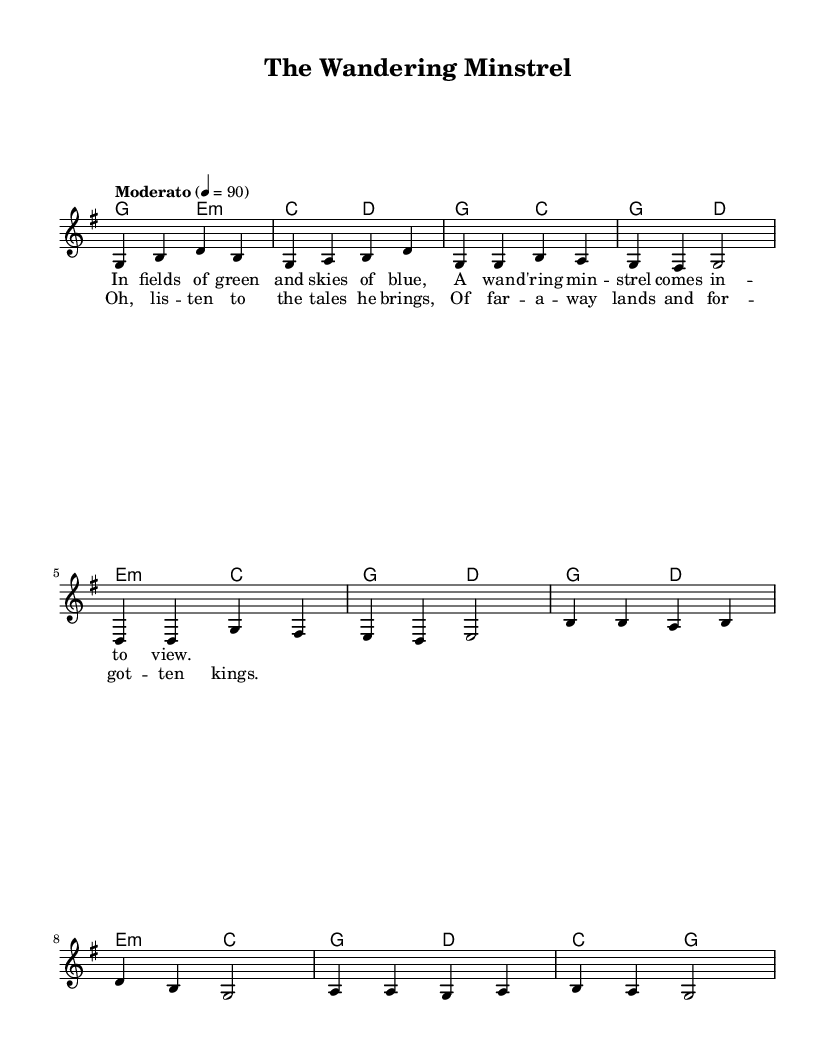What is the key signature of this music? The key signature is G major, which has one sharp (F#). This is determined by the presence of the F# note throughout the piece, characteristic of the G major scale.
Answer: G major What is the time signature of this music? The time signature is 4/4, meaning there are four beats per measure, and a quarter note gets one beat. This can be identified by the notation at the start of the score indicating 4/4.
Answer: 4/4 What is the tempo marking for this piece? The tempo marking is "Moderato," which indicates a moderate tempo. It is given in the header of the music with the metronome marking of 90 beats per minute.
Answer: Moderato How many measures are in the verse section? The verse section consists of four measures. This can be counted by identifying the phrases in the notation and counting each bar line in the verse section.
Answer: 4 What is the primary theme of the lyrics? The primary theme of the lyrics revolves around storytelling and adventure, evident from lines mentioning a wandering minstrel and forgotten kings. The content reflects a tradition of folk music centered on narrative.
Answer: Storytelling What chords are used in the chorus? The chords used in the chorus are G, D, E minor, and C. By analyzing the chord symbols above the notes in the chorus section of the score, one can identify these chords.
Answer: G, D, E minor, C How does the melody primarily move in the chorus? The melody primarily moves by step, meaning it generally progresses by adjacent notes rather than large jumps. This movement is evident by the small pitch interval between successive notes in the chorus.
Answer: By step 